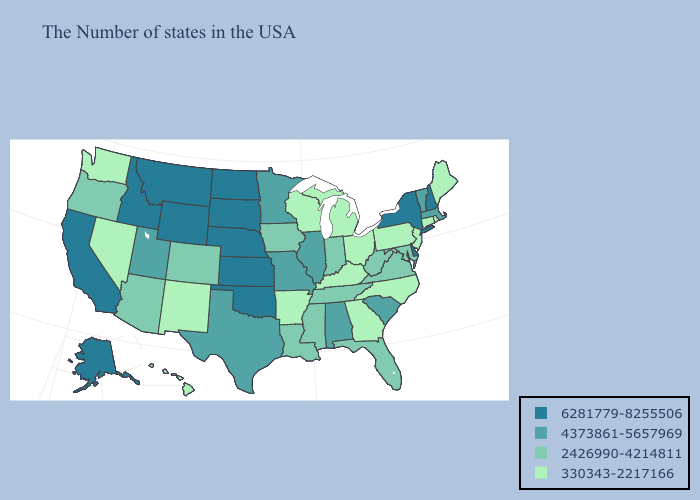Is the legend a continuous bar?
Be succinct. No. How many symbols are there in the legend?
Answer briefly. 4. Which states have the lowest value in the Northeast?
Concise answer only. Maine, Rhode Island, Connecticut, New Jersey, Pennsylvania. Does Indiana have a higher value than Texas?
Answer briefly. No. Does Minnesota have a lower value than Wyoming?
Keep it brief. Yes. Among the states that border Wyoming , which have the lowest value?
Give a very brief answer. Colorado. Name the states that have a value in the range 2426990-4214811?
Keep it brief. Maryland, Virginia, West Virginia, Florida, Indiana, Tennessee, Mississippi, Louisiana, Iowa, Colorado, Arizona, Oregon. Does the first symbol in the legend represent the smallest category?
Concise answer only. No. Is the legend a continuous bar?
Quick response, please. No. What is the highest value in states that border North Dakota?
Write a very short answer. 6281779-8255506. Name the states that have a value in the range 4373861-5657969?
Answer briefly. Massachusetts, Vermont, South Carolina, Alabama, Illinois, Missouri, Minnesota, Texas, Utah. Name the states that have a value in the range 4373861-5657969?
Keep it brief. Massachusetts, Vermont, South Carolina, Alabama, Illinois, Missouri, Minnesota, Texas, Utah. Name the states that have a value in the range 2426990-4214811?
Quick response, please. Maryland, Virginia, West Virginia, Florida, Indiana, Tennessee, Mississippi, Louisiana, Iowa, Colorado, Arizona, Oregon. Among the states that border Mississippi , does Louisiana have the highest value?
Write a very short answer. No. 